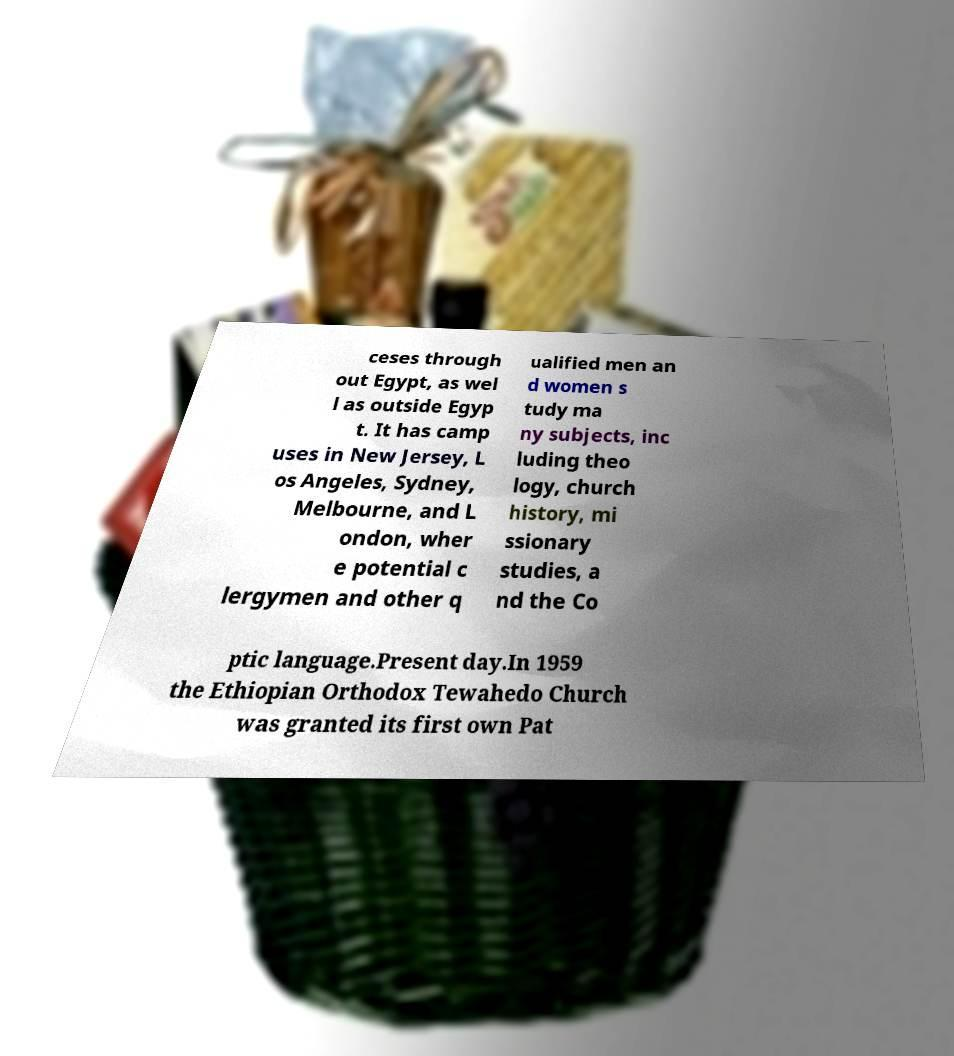Can you accurately transcribe the text from the provided image for me? ceses through out Egypt, as wel l as outside Egyp t. It has camp uses in New Jersey, L os Angeles, Sydney, Melbourne, and L ondon, wher e potential c lergymen and other q ualified men an d women s tudy ma ny subjects, inc luding theo logy, church history, mi ssionary studies, a nd the Co ptic language.Present day.In 1959 the Ethiopian Orthodox Tewahedo Church was granted its first own Pat 